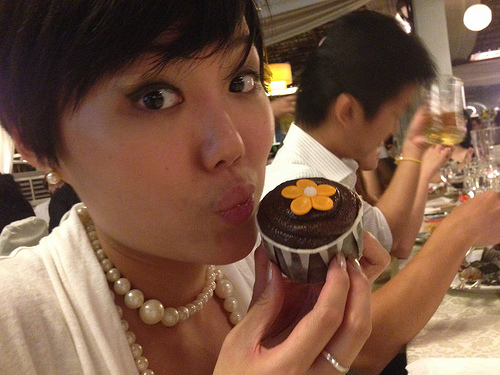Is there a chair at the table? No, there does not appear to be a chair at the table. 